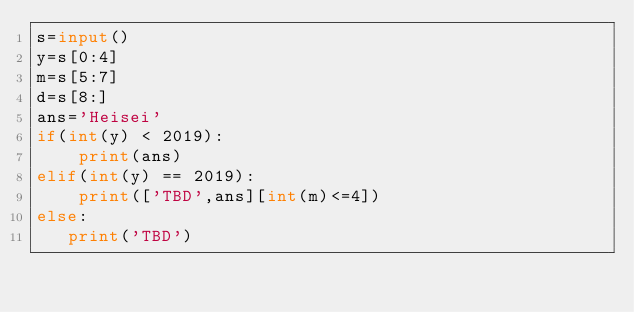Convert code to text. <code><loc_0><loc_0><loc_500><loc_500><_Python_>s=input()
y=s[0:4]
m=s[5:7]
d=s[8:]
ans='Heisei'
if(int(y) < 2019):
    print(ans)
elif(int(y) == 2019):
    print(['TBD',ans][int(m)<=4])
else:
   print('TBD')</code> 